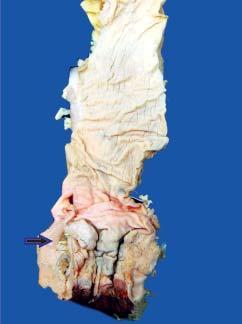what is grey-white and fleshy due to infiltration by the tumour?
Answer the question using a single word or phrase. Color of sectioned surface of rectal wall 